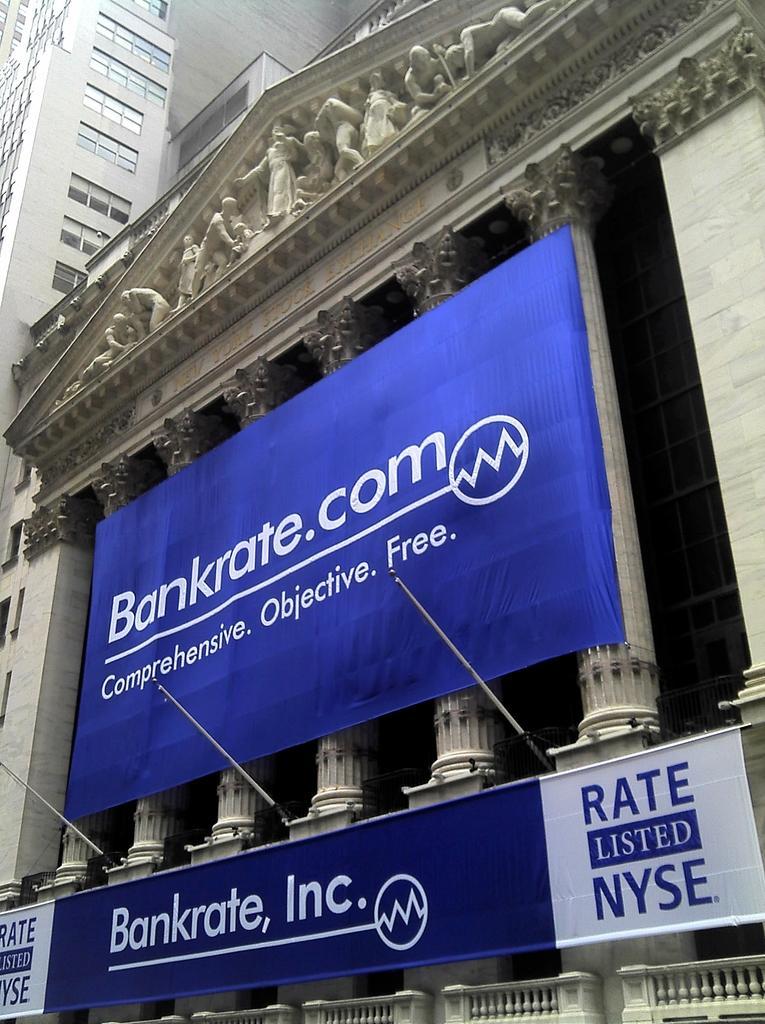Describe this image in one or two sentences. This is the front view of a building where we can see sculptures and banners. At the top of the image, there is a building with glass windows. 